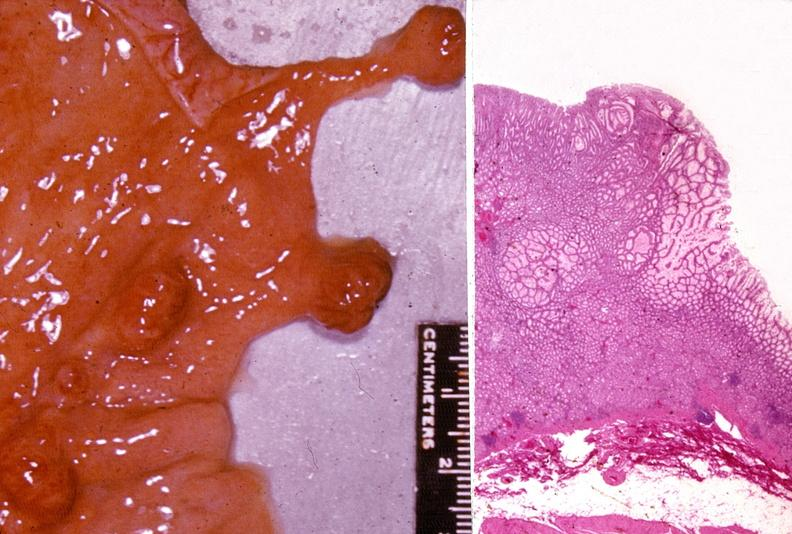does this image show stomach, polyposis, multiple?
Answer the question using a single word or phrase. Yes 